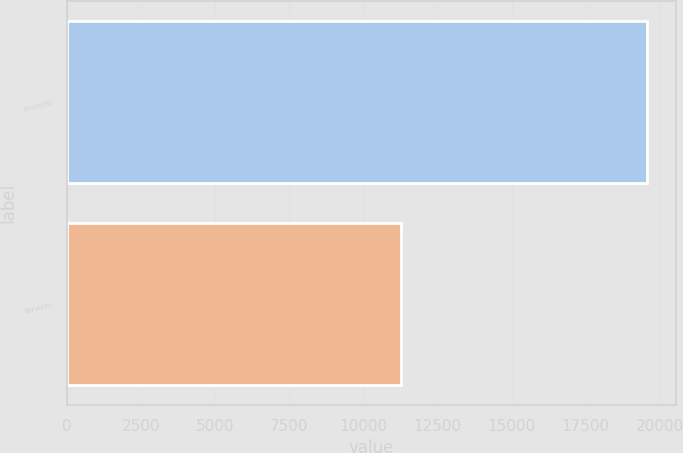<chart> <loc_0><loc_0><loc_500><loc_500><bar_chart><fcel>Products<fcel>Services<nl><fcel>19564<fcel>11288<nl></chart> 